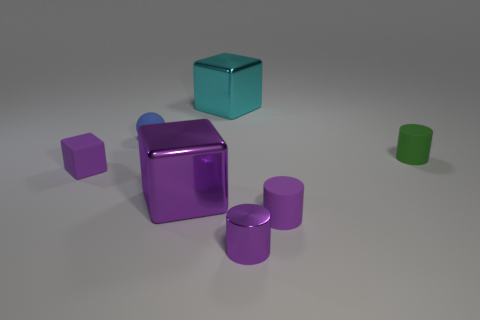Add 2 gray rubber cylinders. How many objects exist? 9 Subtract all spheres. How many objects are left? 6 Subtract 0 cyan balls. How many objects are left? 7 Subtract all red rubber spheres. Subtract all cubes. How many objects are left? 4 Add 1 small spheres. How many small spheres are left? 2 Add 2 big blue metallic cylinders. How many big blue metallic cylinders exist? 2 